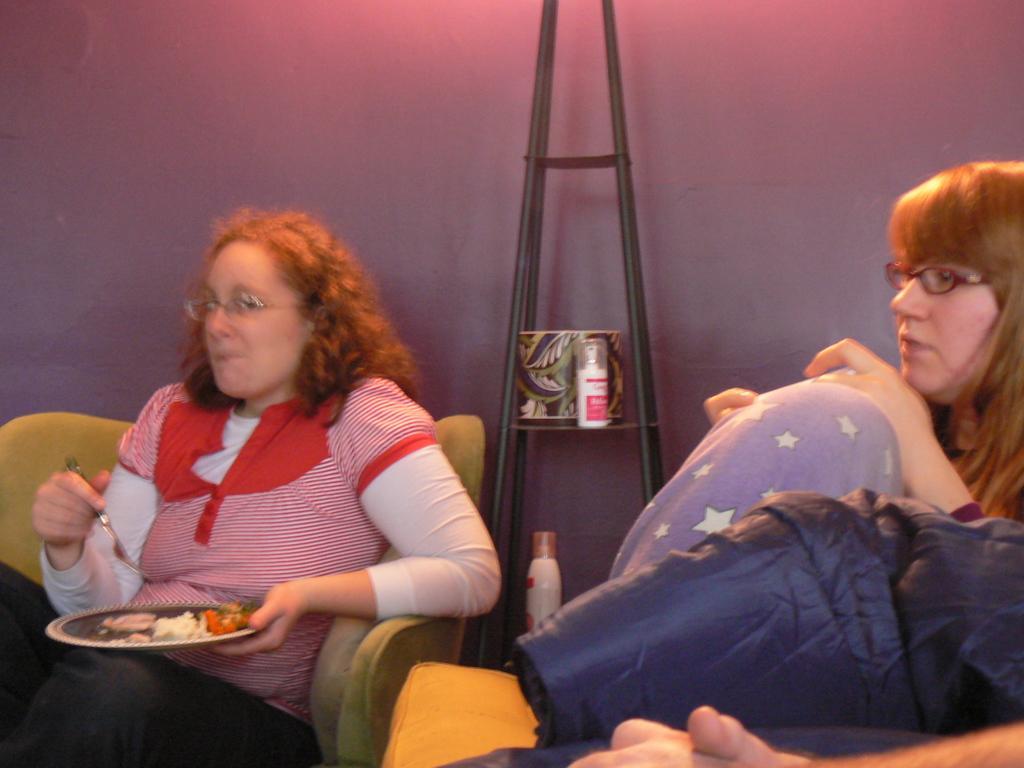How would you summarize this image in a sentence or two? In this picture there are two women sitting on chairs, among them one woman holding a plate with food and fork. We can see bottles and an object on stand and wall. In the bottom right side of the image we can see cloth and hand of a person. 